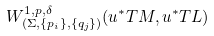Convert formula to latex. <formula><loc_0><loc_0><loc_500><loc_500>W ^ { 1 , p , \delta } _ { \left ( \Sigma , \{ p _ { i } \} , \{ q _ { j } \} \right ) } ( u ^ { * } T M , u ^ { * } T L )</formula> 